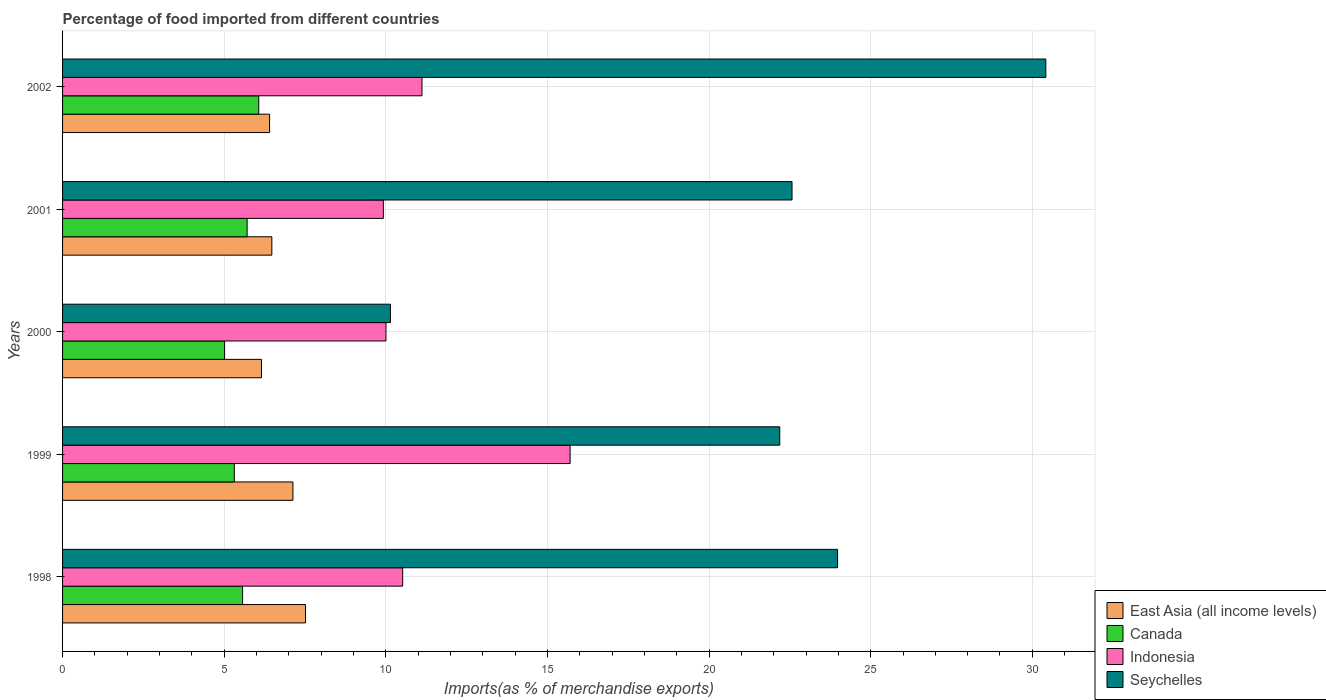How many groups of bars are there?
Make the answer very short. 5. Are the number of bars per tick equal to the number of legend labels?
Your response must be concise. Yes. Are the number of bars on each tick of the Y-axis equal?
Keep it short and to the point. Yes. How many bars are there on the 1st tick from the bottom?
Your answer should be compact. 4. What is the percentage of imports to different countries in Canada in 2002?
Give a very brief answer. 6.07. Across all years, what is the maximum percentage of imports to different countries in Canada?
Ensure brevity in your answer.  6.07. Across all years, what is the minimum percentage of imports to different countries in Seychelles?
Ensure brevity in your answer.  10.14. In which year was the percentage of imports to different countries in Canada maximum?
Ensure brevity in your answer.  2002. In which year was the percentage of imports to different countries in East Asia (all income levels) minimum?
Give a very brief answer. 2000. What is the total percentage of imports to different countries in East Asia (all income levels) in the graph?
Your response must be concise. 33.67. What is the difference between the percentage of imports to different countries in Canada in 1999 and that in 2000?
Your response must be concise. 0.3. What is the difference between the percentage of imports to different countries in Indonesia in 2000 and the percentage of imports to different countries in East Asia (all income levels) in 2002?
Provide a succinct answer. 3.6. What is the average percentage of imports to different countries in East Asia (all income levels) per year?
Make the answer very short. 6.73. In the year 2000, what is the difference between the percentage of imports to different countries in Canada and percentage of imports to different countries in Seychelles?
Offer a very short reply. -5.13. In how many years, is the percentage of imports to different countries in Canada greater than 19 %?
Provide a short and direct response. 0. What is the ratio of the percentage of imports to different countries in Seychelles in 1998 to that in 2002?
Your answer should be very brief. 0.79. Is the percentage of imports to different countries in Seychelles in 1998 less than that in 2000?
Your response must be concise. No. Is the difference between the percentage of imports to different countries in Canada in 1998 and 2000 greater than the difference between the percentage of imports to different countries in Seychelles in 1998 and 2000?
Offer a very short reply. No. What is the difference between the highest and the second highest percentage of imports to different countries in Indonesia?
Give a very brief answer. 4.58. What is the difference between the highest and the lowest percentage of imports to different countries in Seychelles?
Keep it short and to the point. 20.28. Is the sum of the percentage of imports to different countries in Seychelles in 2000 and 2002 greater than the maximum percentage of imports to different countries in Canada across all years?
Provide a succinct answer. Yes. Is it the case that in every year, the sum of the percentage of imports to different countries in Indonesia and percentage of imports to different countries in East Asia (all income levels) is greater than the sum of percentage of imports to different countries in Canada and percentage of imports to different countries in Seychelles?
Ensure brevity in your answer.  No. What does the 1st bar from the bottom in 1998 represents?
Make the answer very short. East Asia (all income levels). Is it the case that in every year, the sum of the percentage of imports to different countries in Indonesia and percentage of imports to different countries in East Asia (all income levels) is greater than the percentage of imports to different countries in Canada?
Make the answer very short. Yes. Are all the bars in the graph horizontal?
Your response must be concise. Yes. What is the difference between two consecutive major ticks on the X-axis?
Offer a very short reply. 5. Does the graph contain grids?
Your answer should be very brief. Yes. Where does the legend appear in the graph?
Offer a terse response. Bottom right. How many legend labels are there?
Your answer should be compact. 4. What is the title of the graph?
Your answer should be very brief. Percentage of food imported from different countries. What is the label or title of the X-axis?
Offer a very short reply. Imports(as % of merchandise exports). What is the Imports(as % of merchandise exports) of East Asia (all income levels) in 1998?
Provide a succinct answer. 7.52. What is the Imports(as % of merchandise exports) in Canada in 1998?
Provide a short and direct response. 5.57. What is the Imports(as % of merchandise exports) in Indonesia in 1998?
Offer a terse response. 10.52. What is the Imports(as % of merchandise exports) in Seychelles in 1998?
Provide a short and direct response. 23.98. What is the Imports(as % of merchandise exports) in East Asia (all income levels) in 1999?
Give a very brief answer. 7.13. What is the Imports(as % of merchandise exports) in Canada in 1999?
Your answer should be compact. 5.31. What is the Imports(as % of merchandise exports) in Indonesia in 1999?
Your response must be concise. 15.7. What is the Imports(as % of merchandise exports) in Seychelles in 1999?
Give a very brief answer. 22.19. What is the Imports(as % of merchandise exports) of East Asia (all income levels) in 2000?
Give a very brief answer. 6.15. What is the Imports(as % of merchandise exports) in Canada in 2000?
Your response must be concise. 5.01. What is the Imports(as % of merchandise exports) of Indonesia in 2000?
Offer a terse response. 10. What is the Imports(as % of merchandise exports) of Seychelles in 2000?
Keep it short and to the point. 10.14. What is the Imports(as % of merchandise exports) in East Asia (all income levels) in 2001?
Provide a succinct answer. 6.47. What is the Imports(as % of merchandise exports) in Canada in 2001?
Provide a succinct answer. 5.71. What is the Imports(as % of merchandise exports) of Indonesia in 2001?
Ensure brevity in your answer.  9.92. What is the Imports(as % of merchandise exports) of Seychelles in 2001?
Make the answer very short. 22.57. What is the Imports(as % of merchandise exports) of East Asia (all income levels) in 2002?
Ensure brevity in your answer.  6.4. What is the Imports(as % of merchandise exports) in Canada in 2002?
Make the answer very short. 6.07. What is the Imports(as % of merchandise exports) in Indonesia in 2002?
Keep it short and to the point. 11.12. What is the Imports(as % of merchandise exports) of Seychelles in 2002?
Keep it short and to the point. 30.42. Across all years, what is the maximum Imports(as % of merchandise exports) in East Asia (all income levels)?
Give a very brief answer. 7.52. Across all years, what is the maximum Imports(as % of merchandise exports) in Canada?
Your answer should be very brief. 6.07. Across all years, what is the maximum Imports(as % of merchandise exports) of Indonesia?
Your answer should be very brief. 15.7. Across all years, what is the maximum Imports(as % of merchandise exports) in Seychelles?
Provide a succinct answer. 30.42. Across all years, what is the minimum Imports(as % of merchandise exports) of East Asia (all income levels)?
Your response must be concise. 6.15. Across all years, what is the minimum Imports(as % of merchandise exports) of Canada?
Provide a short and direct response. 5.01. Across all years, what is the minimum Imports(as % of merchandise exports) in Indonesia?
Keep it short and to the point. 9.92. Across all years, what is the minimum Imports(as % of merchandise exports) of Seychelles?
Give a very brief answer. 10.14. What is the total Imports(as % of merchandise exports) in East Asia (all income levels) in the graph?
Make the answer very short. 33.67. What is the total Imports(as % of merchandise exports) of Canada in the graph?
Ensure brevity in your answer.  27.67. What is the total Imports(as % of merchandise exports) of Indonesia in the graph?
Offer a very short reply. 57.27. What is the total Imports(as % of merchandise exports) of Seychelles in the graph?
Offer a very short reply. 109.29. What is the difference between the Imports(as % of merchandise exports) of East Asia (all income levels) in 1998 and that in 1999?
Provide a short and direct response. 0.39. What is the difference between the Imports(as % of merchandise exports) of Canada in 1998 and that in 1999?
Provide a short and direct response. 0.26. What is the difference between the Imports(as % of merchandise exports) in Indonesia in 1998 and that in 1999?
Provide a succinct answer. -5.18. What is the difference between the Imports(as % of merchandise exports) of Seychelles in 1998 and that in 1999?
Offer a terse response. 1.79. What is the difference between the Imports(as % of merchandise exports) in East Asia (all income levels) in 1998 and that in 2000?
Your response must be concise. 1.36. What is the difference between the Imports(as % of merchandise exports) of Canada in 1998 and that in 2000?
Make the answer very short. 0.56. What is the difference between the Imports(as % of merchandise exports) in Indonesia in 1998 and that in 2000?
Ensure brevity in your answer.  0.52. What is the difference between the Imports(as % of merchandise exports) in Seychelles in 1998 and that in 2000?
Give a very brief answer. 13.83. What is the difference between the Imports(as % of merchandise exports) in East Asia (all income levels) in 1998 and that in 2001?
Give a very brief answer. 1.04. What is the difference between the Imports(as % of merchandise exports) of Canada in 1998 and that in 2001?
Make the answer very short. -0.14. What is the difference between the Imports(as % of merchandise exports) in Indonesia in 1998 and that in 2001?
Offer a very short reply. 0.6. What is the difference between the Imports(as % of merchandise exports) of Seychelles in 1998 and that in 2001?
Your answer should be very brief. 1.41. What is the difference between the Imports(as % of merchandise exports) of East Asia (all income levels) in 1998 and that in 2002?
Your answer should be compact. 1.11. What is the difference between the Imports(as % of merchandise exports) in Canada in 1998 and that in 2002?
Provide a succinct answer. -0.5. What is the difference between the Imports(as % of merchandise exports) in Indonesia in 1998 and that in 2002?
Your response must be concise. -0.6. What is the difference between the Imports(as % of merchandise exports) in Seychelles in 1998 and that in 2002?
Your answer should be compact. -6.44. What is the difference between the Imports(as % of merchandise exports) in East Asia (all income levels) in 1999 and that in 2000?
Your answer should be compact. 0.97. What is the difference between the Imports(as % of merchandise exports) of Canada in 1999 and that in 2000?
Your answer should be very brief. 0.3. What is the difference between the Imports(as % of merchandise exports) of Indonesia in 1999 and that in 2000?
Your response must be concise. 5.7. What is the difference between the Imports(as % of merchandise exports) of Seychelles in 1999 and that in 2000?
Make the answer very short. 12.04. What is the difference between the Imports(as % of merchandise exports) in East Asia (all income levels) in 1999 and that in 2001?
Your answer should be compact. 0.65. What is the difference between the Imports(as % of merchandise exports) of Canada in 1999 and that in 2001?
Ensure brevity in your answer.  -0.4. What is the difference between the Imports(as % of merchandise exports) in Indonesia in 1999 and that in 2001?
Make the answer very short. 5.78. What is the difference between the Imports(as % of merchandise exports) in Seychelles in 1999 and that in 2001?
Keep it short and to the point. -0.38. What is the difference between the Imports(as % of merchandise exports) in East Asia (all income levels) in 1999 and that in 2002?
Your response must be concise. 0.72. What is the difference between the Imports(as % of merchandise exports) of Canada in 1999 and that in 2002?
Keep it short and to the point. -0.76. What is the difference between the Imports(as % of merchandise exports) of Indonesia in 1999 and that in 2002?
Your answer should be very brief. 4.58. What is the difference between the Imports(as % of merchandise exports) of Seychelles in 1999 and that in 2002?
Provide a succinct answer. -8.23. What is the difference between the Imports(as % of merchandise exports) in East Asia (all income levels) in 2000 and that in 2001?
Offer a very short reply. -0.32. What is the difference between the Imports(as % of merchandise exports) of Canada in 2000 and that in 2001?
Give a very brief answer. -0.7. What is the difference between the Imports(as % of merchandise exports) of Indonesia in 2000 and that in 2001?
Your response must be concise. 0.08. What is the difference between the Imports(as % of merchandise exports) in Seychelles in 2000 and that in 2001?
Provide a succinct answer. -12.42. What is the difference between the Imports(as % of merchandise exports) in East Asia (all income levels) in 2000 and that in 2002?
Your answer should be compact. -0.25. What is the difference between the Imports(as % of merchandise exports) in Canada in 2000 and that in 2002?
Your answer should be very brief. -1.06. What is the difference between the Imports(as % of merchandise exports) of Indonesia in 2000 and that in 2002?
Provide a short and direct response. -1.11. What is the difference between the Imports(as % of merchandise exports) of Seychelles in 2000 and that in 2002?
Your answer should be very brief. -20.28. What is the difference between the Imports(as % of merchandise exports) of East Asia (all income levels) in 2001 and that in 2002?
Provide a succinct answer. 0.07. What is the difference between the Imports(as % of merchandise exports) of Canada in 2001 and that in 2002?
Offer a terse response. -0.36. What is the difference between the Imports(as % of merchandise exports) in Indonesia in 2001 and that in 2002?
Provide a succinct answer. -1.2. What is the difference between the Imports(as % of merchandise exports) in Seychelles in 2001 and that in 2002?
Provide a short and direct response. -7.85. What is the difference between the Imports(as % of merchandise exports) in East Asia (all income levels) in 1998 and the Imports(as % of merchandise exports) in Canada in 1999?
Offer a terse response. 2.2. What is the difference between the Imports(as % of merchandise exports) in East Asia (all income levels) in 1998 and the Imports(as % of merchandise exports) in Indonesia in 1999?
Your response must be concise. -8.19. What is the difference between the Imports(as % of merchandise exports) of East Asia (all income levels) in 1998 and the Imports(as % of merchandise exports) of Seychelles in 1999?
Offer a terse response. -14.67. What is the difference between the Imports(as % of merchandise exports) in Canada in 1998 and the Imports(as % of merchandise exports) in Indonesia in 1999?
Provide a succinct answer. -10.13. What is the difference between the Imports(as % of merchandise exports) of Canada in 1998 and the Imports(as % of merchandise exports) of Seychelles in 1999?
Provide a succinct answer. -16.62. What is the difference between the Imports(as % of merchandise exports) in Indonesia in 1998 and the Imports(as % of merchandise exports) in Seychelles in 1999?
Your answer should be very brief. -11.67. What is the difference between the Imports(as % of merchandise exports) of East Asia (all income levels) in 1998 and the Imports(as % of merchandise exports) of Canada in 2000?
Provide a short and direct response. 2.5. What is the difference between the Imports(as % of merchandise exports) of East Asia (all income levels) in 1998 and the Imports(as % of merchandise exports) of Indonesia in 2000?
Ensure brevity in your answer.  -2.49. What is the difference between the Imports(as % of merchandise exports) in East Asia (all income levels) in 1998 and the Imports(as % of merchandise exports) in Seychelles in 2000?
Your answer should be compact. -2.63. What is the difference between the Imports(as % of merchandise exports) of Canada in 1998 and the Imports(as % of merchandise exports) of Indonesia in 2000?
Provide a succinct answer. -4.44. What is the difference between the Imports(as % of merchandise exports) in Canada in 1998 and the Imports(as % of merchandise exports) in Seychelles in 2000?
Your response must be concise. -4.57. What is the difference between the Imports(as % of merchandise exports) of Indonesia in 1998 and the Imports(as % of merchandise exports) of Seychelles in 2000?
Offer a terse response. 0.38. What is the difference between the Imports(as % of merchandise exports) in East Asia (all income levels) in 1998 and the Imports(as % of merchandise exports) in Canada in 2001?
Your answer should be compact. 1.81. What is the difference between the Imports(as % of merchandise exports) in East Asia (all income levels) in 1998 and the Imports(as % of merchandise exports) in Indonesia in 2001?
Your answer should be very brief. -2.41. What is the difference between the Imports(as % of merchandise exports) in East Asia (all income levels) in 1998 and the Imports(as % of merchandise exports) in Seychelles in 2001?
Keep it short and to the point. -15.05. What is the difference between the Imports(as % of merchandise exports) of Canada in 1998 and the Imports(as % of merchandise exports) of Indonesia in 2001?
Provide a short and direct response. -4.35. What is the difference between the Imports(as % of merchandise exports) of Canada in 1998 and the Imports(as % of merchandise exports) of Seychelles in 2001?
Offer a very short reply. -17. What is the difference between the Imports(as % of merchandise exports) of Indonesia in 1998 and the Imports(as % of merchandise exports) of Seychelles in 2001?
Provide a short and direct response. -12.04. What is the difference between the Imports(as % of merchandise exports) of East Asia (all income levels) in 1998 and the Imports(as % of merchandise exports) of Canada in 2002?
Your response must be concise. 1.45. What is the difference between the Imports(as % of merchandise exports) of East Asia (all income levels) in 1998 and the Imports(as % of merchandise exports) of Indonesia in 2002?
Provide a short and direct response. -3.6. What is the difference between the Imports(as % of merchandise exports) of East Asia (all income levels) in 1998 and the Imports(as % of merchandise exports) of Seychelles in 2002?
Provide a short and direct response. -22.9. What is the difference between the Imports(as % of merchandise exports) in Canada in 1998 and the Imports(as % of merchandise exports) in Indonesia in 2002?
Your response must be concise. -5.55. What is the difference between the Imports(as % of merchandise exports) in Canada in 1998 and the Imports(as % of merchandise exports) in Seychelles in 2002?
Give a very brief answer. -24.85. What is the difference between the Imports(as % of merchandise exports) of Indonesia in 1998 and the Imports(as % of merchandise exports) of Seychelles in 2002?
Your answer should be compact. -19.9. What is the difference between the Imports(as % of merchandise exports) in East Asia (all income levels) in 1999 and the Imports(as % of merchandise exports) in Canada in 2000?
Give a very brief answer. 2.11. What is the difference between the Imports(as % of merchandise exports) of East Asia (all income levels) in 1999 and the Imports(as % of merchandise exports) of Indonesia in 2000?
Keep it short and to the point. -2.88. What is the difference between the Imports(as % of merchandise exports) of East Asia (all income levels) in 1999 and the Imports(as % of merchandise exports) of Seychelles in 2000?
Your answer should be very brief. -3.02. What is the difference between the Imports(as % of merchandise exports) of Canada in 1999 and the Imports(as % of merchandise exports) of Indonesia in 2000?
Provide a short and direct response. -4.69. What is the difference between the Imports(as % of merchandise exports) of Canada in 1999 and the Imports(as % of merchandise exports) of Seychelles in 2000?
Your answer should be compact. -4.83. What is the difference between the Imports(as % of merchandise exports) in Indonesia in 1999 and the Imports(as % of merchandise exports) in Seychelles in 2000?
Keep it short and to the point. 5.56. What is the difference between the Imports(as % of merchandise exports) in East Asia (all income levels) in 1999 and the Imports(as % of merchandise exports) in Canada in 2001?
Offer a terse response. 1.42. What is the difference between the Imports(as % of merchandise exports) of East Asia (all income levels) in 1999 and the Imports(as % of merchandise exports) of Indonesia in 2001?
Provide a short and direct response. -2.8. What is the difference between the Imports(as % of merchandise exports) in East Asia (all income levels) in 1999 and the Imports(as % of merchandise exports) in Seychelles in 2001?
Offer a very short reply. -15.44. What is the difference between the Imports(as % of merchandise exports) of Canada in 1999 and the Imports(as % of merchandise exports) of Indonesia in 2001?
Offer a terse response. -4.61. What is the difference between the Imports(as % of merchandise exports) of Canada in 1999 and the Imports(as % of merchandise exports) of Seychelles in 2001?
Keep it short and to the point. -17.25. What is the difference between the Imports(as % of merchandise exports) of Indonesia in 1999 and the Imports(as % of merchandise exports) of Seychelles in 2001?
Offer a terse response. -6.87. What is the difference between the Imports(as % of merchandise exports) of East Asia (all income levels) in 1999 and the Imports(as % of merchandise exports) of Canada in 2002?
Provide a short and direct response. 1.06. What is the difference between the Imports(as % of merchandise exports) of East Asia (all income levels) in 1999 and the Imports(as % of merchandise exports) of Indonesia in 2002?
Offer a very short reply. -3.99. What is the difference between the Imports(as % of merchandise exports) of East Asia (all income levels) in 1999 and the Imports(as % of merchandise exports) of Seychelles in 2002?
Provide a succinct answer. -23.29. What is the difference between the Imports(as % of merchandise exports) of Canada in 1999 and the Imports(as % of merchandise exports) of Indonesia in 2002?
Make the answer very short. -5.81. What is the difference between the Imports(as % of merchandise exports) of Canada in 1999 and the Imports(as % of merchandise exports) of Seychelles in 2002?
Offer a terse response. -25.11. What is the difference between the Imports(as % of merchandise exports) in Indonesia in 1999 and the Imports(as % of merchandise exports) in Seychelles in 2002?
Your answer should be compact. -14.72. What is the difference between the Imports(as % of merchandise exports) in East Asia (all income levels) in 2000 and the Imports(as % of merchandise exports) in Canada in 2001?
Your answer should be very brief. 0.44. What is the difference between the Imports(as % of merchandise exports) of East Asia (all income levels) in 2000 and the Imports(as % of merchandise exports) of Indonesia in 2001?
Make the answer very short. -3.77. What is the difference between the Imports(as % of merchandise exports) of East Asia (all income levels) in 2000 and the Imports(as % of merchandise exports) of Seychelles in 2001?
Give a very brief answer. -16.41. What is the difference between the Imports(as % of merchandise exports) in Canada in 2000 and the Imports(as % of merchandise exports) in Indonesia in 2001?
Provide a succinct answer. -4.91. What is the difference between the Imports(as % of merchandise exports) of Canada in 2000 and the Imports(as % of merchandise exports) of Seychelles in 2001?
Offer a terse response. -17.55. What is the difference between the Imports(as % of merchandise exports) in Indonesia in 2000 and the Imports(as % of merchandise exports) in Seychelles in 2001?
Offer a terse response. -12.56. What is the difference between the Imports(as % of merchandise exports) in East Asia (all income levels) in 2000 and the Imports(as % of merchandise exports) in Canada in 2002?
Offer a very short reply. 0.08. What is the difference between the Imports(as % of merchandise exports) of East Asia (all income levels) in 2000 and the Imports(as % of merchandise exports) of Indonesia in 2002?
Offer a terse response. -4.97. What is the difference between the Imports(as % of merchandise exports) of East Asia (all income levels) in 2000 and the Imports(as % of merchandise exports) of Seychelles in 2002?
Your response must be concise. -24.27. What is the difference between the Imports(as % of merchandise exports) in Canada in 2000 and the Imports(as % of merchandise exports) in Indonesia in 2002?
Keep it short and to the point. -6.11. What is the difference between the Imports(as % of merchandise exports) in Canada in 2000 and the Imports(as % of merchandise exports) in Seychelles in 2002?
Offer a terse response. -25.41. What is the difference between the Imports(as % of merchandise exports) in Indonesia in 2000 and the Imports(as % of merchandise exports) in Seychelles in 2002?
Offer a very short reply. -20.41. What is the difference between the Imports(as % of merchandise exports) of East Asia (all income levels) in 2001 and the Imports(as % of merchandise exports) of Canada in 2002?
Your response must be concise. 0.4. What is the difference between the Imports(as % of merchandise exports) in East Asia (all income levels) in 2001 and the Imports(as % of merchandise exports) in Indonesia in 2002?
Ensure brevity in your answer.  -4.65. What is the difference between the Imports(as % of merchandise exports) of East Asia (all income levels) in 2001 and the Imports(as % of merchandise exports) of Seychelles in 2002?
Make the answer very short. -23.94. What is the difference between the Imports(as % of merchandise exports) in Canada in 2001 and the Imports(as % of merchandise exports) in Indonesia in 2002?
Your answer should be compact. -5.41. What is the difference between the Imports(as % of merchandise exports) of Canada in 2001 and the Imports(as % of merchandise exports) of Seychelles in 2002?
Ensure brevity in your answer.  -24.71. What is the difference between the Imports(as % of merchandise exports) in Indonesia in 2001 and the Imports(as % of merchandise exports) in Seychelles in 2002?
Your response must be concise. -20.49. What is the average Imports(as % of merchandise exports) of East Asia (all income levels) per year?
Provide a short and direct response. 6.73. What is the average Imports(as % of merchandise exports) in Canada per year?
Offer a terse response. 5.53. What is the average Imports(as % of merchandise exports) of Indonesia per year?
Keep it short and to the point. 11.45. What is the average Imports(as % of merchandise exports) in Seychelles per year?
Give a very brief answer. 21.86. In the year 1998, what is the difference between the Imports(as % of merchandise exports) of East Asia (all income levels) and Imports(as % of merchandise exports) of Canada?
Your answer should be compact. 1.95. In the year 1998, what is the difference between the Imports(as % of merchandise exports) in East Asia (all income levels) and Imports(as % of merchandise exports) in Indonesia?
Your response must be concise. -3.01. In the year 1998, what is the difference between the Imports(as % of merchandise exports) of East Asia (all income levels) and Imports(as % of merchandise exports) of Seychelles?
Your answer should be compact. -16.46. In the year 1998, what is the difference between the Imports(as % of merchandise exports) of Canada and Imports(as % of merchandise exports) of Indonesia?
Your answer should be compact. -4.95. In the year 1998, what is the difference between the Imports(as % of merchandise exports) in Canada and Imports(as % of merchandise exports) in Seychelles?
Provide a short and direct response. -18.41. In the year 1998, what is the difference between the Imports(as % of merchandise exports) in Indonesia and Imports(as % of merchandise exports) in Seychelles?
Offer a terse response. -13.45. In the year 1999, what is the difference between the Imports(as % of merchandise exports) in East Asia (all income levels) and Imports(as % of merchandise exports) in Canada?
Keep it short and to the point. 1.81. In the year 1999, what is the difference between the Imports(as % of merchandise exports) in East Asia (all income levels) and Imports(as % of merchandise exports) in Indonesia?
Provide a short and direct response. -8.57. In the year 1999, what is the difference between the Imports(as % of merchandise exports) of East Asia (all income levels) and Imports(as % of merchandise exports) of Seychelles?
Your answer should be very brief. -15.06. In the year 1999, what is the difference between the Imports(as % of merchandise exports) of Canada and Imports(as % of merchandise exports) of Indonesia?
Ensure brevity in your answer.  -10.39. In the year 1999, what is the difference between the Imports(as % of merchandise exports) of Canada and Imports(as % of merchandise exports) of Seychelles?
Offer a terse response. -16.87. In the year 1999, what is the difference between the Imports(as % of merchandise exports) of Indonesia and Imports(as % of merchandise exports) of Seychelles?
Your answer should be very brief. -6.49. In the year 2000, what is the difference between the Imports(as % of merchandise exports) in East Asia (all income levels) and Imports(as % of merchandise exports) in Canada?
Ensure brevity in your answer.  1.14. In the year 2000, what is the difference between the Imports(as % of merchandise exports) of East Asia (all income levels) and Imports(as % of merchandise exports) of Indonesia?
Offer a terse response. -3.85. In the year 2000, what is the difference between the Imports(as % of merchandise exports) of East Asia (all income levels) and Imports(as % of merchandise exports) of Seychelles?
Ensure brevity in your answer.  -3.99. In the year 2000, what is the difference between the Imports(as % of merchandise exports) in Canada and Imports(as % of merchandise exports) in Indonesia?
Your answer should be very brief. -4.99. In the year 2000, what is the difference between the Imports(as % of merchandise exports) in Canada and Imports(as % of merchandise exports) in Seychelles?
Provide a short and direct response. -5.13. In the year 2000, what is the difference between the Imports(as % of merchandise exports) of Indonesia and Imports(as % of merchandise exports) of Seychelles?
Give a very brief answer. -0.14. In the year 2001, what is the difference between the Imports(as % of merchandise exports) of East Asia (all income levels) and Imports(as % of merchandise exports) of Canada?
Make the answer very short. 0.76. In the year 2001, what is the difference between the Imports(as % of merchandise exports) of East Asia (all income levels) and Imports(as % of merchandise exports) of Indonesia?
Your response must be concise. -3.45. In the year 2001, what is the difference between the Imports(as % of merchandise exports) of East Asia (all income levels) and Imports(as % of merchandise exports) of Seychelles?
Make the answer very short. -16.09. In the year 2001, what is the difference between the Imports(as % of merchandise exports) of Canada and Imports(as % of merchandise exports) of Indonesia?
Provide a succinct answer. -4.21. In the year 2001, what is the difference between the Imports(as % of merchandise exports) in Canada and Imports(as % of merchandise exports) in Seychelles?
Your answer should be very brief. -16.86. In the year 2001, what is the difference between the Imports(as % of merchandise exports) of Indonesia and Imports(as % of merchandise exports) of Seychelles?
Keep it short and to the point. -12.64. In the year 2002, what is the difference between the Imports(as % of merchandise exports) of East Asia (all income levels) and Imports(as % of merchandise exports) of Canada?
Provide a succinct answer. 0.34. In the year 2002, what is the difference between the Imports(as % of merchandise exports) of East Asia (all income levels) and Imports(as % of merchandise exports) of Indonesia?
Provide a succinct answer. -4.71. In the year 2002, what is the difference between the Imports(as % of merchandise exports) in East Asia (all income levels) and Imports(as % of merchandise exports) in Seychelles?
Make the answer very short. -24.01. In the year 2002, what is the difference between the Imports(as % of merchandise exports) in Canada and Imports(as % of merchandise exports) in Indonesia?
Offer a very short reply. -5.05. In the year 2002, what is the difference between the Imports(as % of merchandise exports) of Canada and Imports(as % of merchandise exports) of Seychelles?
Your response must be concise. -24.35. In the year 2002, what is the difference between the Imports(as % of merchandise exports) of Indonesia and Imports(as % of merchandise exports) of Seychelles?
Ensure brevity in your answer.  -19.3. What is the ratio of the Imports(as % of merchandise exports) in East Asia (all income levels) in 1998 to that in 1999?
Offer a terse response. 1.05. What is the ratio of the Imports(as % of merchandise exports) of Canada in 1998 to that in 1999?
Your answer should be compact. 1.05. What is the ratio of the Imports(as % of merchandise exports) in Indonesia in 1998 to that in 1999?
Provide a succinct answer. 0.67. What is the ratio of the Imports(as % of merchandise exports) of Seychelles in 1998 to that in 1999?
Keep it short and to the point. 1.08. What is the ratio of the Imports(as % of merchandise exports) in East Asia (all income levels) in 1998 to that in 2000?
Your answer should be compact. 1.22. What is the ratio of the Imports(as % of merchandise exports) in Canada in 1998 to that in 2000?
Ensure brevity in your answer.  1.11. What is the ratio of the Imports(as % of merchandise exports) in Indonesia in 1998 to that in 2000?
Offer a terse response. 1.05. What is the ratio of the Imports(as % of merchandise exports) of Seychelles in 1998 to that in 2000?
Your response must be concise. 2.36. What is the ratio of the Imports(as % of merchandise exports) in East Asia (all income levels) in 1998 to that in 2001?
Offer a very short reply. 1.16. What is the ratio of the Imports(as % of merchandise exports) in Canada in 1998 to that in 2001?
Make the answer very short. 0.98. What is the ratio of the Imports(as % of merchandise exports) of Indonesia in 1998 to that in 2001?
Offer a very short reply. 1.06. What is the ratio of the Imports(as % of merchandise exports) in Seychelles in 1998 to that in 2001?
Provide a succinct answer. 1.06. What is the ratio of the Imports(as % of merchandise exports) in East Asia (all income levels) in 1998 to that in 2002?
Make the answer very short. 1.17. What is the ratio of the Imports(as % of merchandise exports) of Canada in 1998 to that in 2002?
Your response must be concise. 0.92. What is the ratio of the Imports(as % of merchandise exports) of Indonesia in 1998 to that in 2002?
Provide a short and direct response. 0.95. What is the ratio of the Imports(as % of merchandise exports) of Seychelles in 1998 to that in 2002?
Provide a succinct answer. 0.79. What is the ratio of the Imports(as % of merchandise exports) of East Asia (all income levels) in 1999 to that in 2000?
Offer a terse response. 1.16. What is the ratio of the Imports(as % of merchandise exports) of Canada in 1999 to that in 2000?
Your response must be concise. 1.06. What is the ratio of the Imports(as % of merchandise exports) of Indonesia in 1999 to that in 2000?
Offer a very short reply. 1.57. What is the ratio of the Imports(as % of merchandise exports) in Seychelles in 1999 to that in 2000?
Keep it short and to the point. 2.19. What is the ratio of the Imports(as % of merchandise exports) in East Asia (all income levels) in 1999 to that in 2001?
Provide a short and direct response. 1.1. What is the ratio of the Imports(as % of merchandise exports) in Canada in 1999 to that in 2001?
Make the answer very short. 0.93. What is the ratio of the Imports(as % of merchandise exports) in Indonesia in 1999 to that in 2001?
Make the answer very short. 1.58. What is the ratio of the Imports(as % of merchandise exports) in Seychelles in 1999 to that in 2001?
Your response must be concise. 0.98. What is the ratio of the Imports(as % of merchandise exports) in East Asia (all income levels) in 1999 to that in 2002?
Give a very brief answer. 1.11. What is the ratio of the Imports(as % of merchandise exports) of Canada in 1999 to that in 2002?
Offer a terse response. 0.88. What is the ratio of the Imports(as % of merchandise exports) in Indonesia in 1999 to that in 2002?
Your answer should be very brief. 1.41. What is the ratio of the Imports(as % of merchandise exports) in Seychelles in 1999 to that in 2002?
Your answer should be compact. 0.73. What is the ratio of the Imports(as % of merchandise exports) in East Asia (all income levels) in 2000 to that in 2001?
Provide a short and direct response. 0.95. What is the ratio of the Imports(as % of merchandise exports) in Canada in 2000 to that in 2001?
Provide a short and direct response. 0.88. What is the ratio of the Imports(as % of merchandise exports) of Indonesia in 2000 to that in 2001?
Keep it short and to the point. 1.01. What is the ratio of the Imports(as % of merchandise exports) of Seychelles in 2000 to that in 2001?
Keep it short and to the point. 0.45. What is the ratio of the Imports(as % of merchandise exports) of East Asia (all income levels) in 2000 to that in 2002?
Make the answer very short. 0.96. What is the ratio of the Imports(as % of merchandise exports) of Canada in 2000 to that in 2002?
Your response must be concise. 0.83. What is the ratio of the Imports(as % of merchandise exports) in Indonesia in 2000 to that in 2002?
Give a very brief answer. 0.9. What is the ratio of the Imports(as % of merchandise exports) of Seychelles in 2000 to that in 2002?
Keep it short and to the point. 0.33. What is the ratio of the Imports(as % of merchandise exports) in East Asia (all income levels) in 2001 to that in 2002?
Offer a very short reply. 1.01. What is the ratio of the Imports(as % of merchandise exports) of Canada in 2001 to that in 2002?
Your response must be concise. 0.94. What is the ratio of the Imports(as % of merchandise exports) in Indonesia in 2001 to that in 2002?
Your answer should be very brief. 0.89. What is the ratio of the Imports(as % of merchandise exports) of Seychelles in 2001 to that in 2002?
Make the answer very short. 0.74. What is the difference between the highest and the second highest Imports(as % of merchandise exports) of East Asia (all income levels)?
Ensure brevity in your answer.  0.39. What is the difference between the highest and the second highest Imports(as % of merchandise exports) of Canada?
Make the answer very short. 0.36. What is the difference between the highest and the second highest Imports(as % of merchandise exports) in Indonesia?
Your response must be concise. 4.58. What is the difference between the highest and the second highest Imports(as % of merchandise exports) of Seychelles?
Offer a terse response. 6.44. What is the difference between the highest and the lowest Imports(as % of merchandise exports) of East Asia (all income levels)?
Provide a succinct answer. 1.36. What is the difference between the highest and the lowest Imports(as % of merchandise exports) in Canada?
Make the answer very short. 1.06. What is the difference between the highest and the lowest Imports(as % of merchandise exports) of Indonesia?
Your answer should be compact. 5.78. What is the difference between the highest and the lowest Imports(as % of merchandise exports) in Seychelles?
Your answer should be compact. 20.28. 